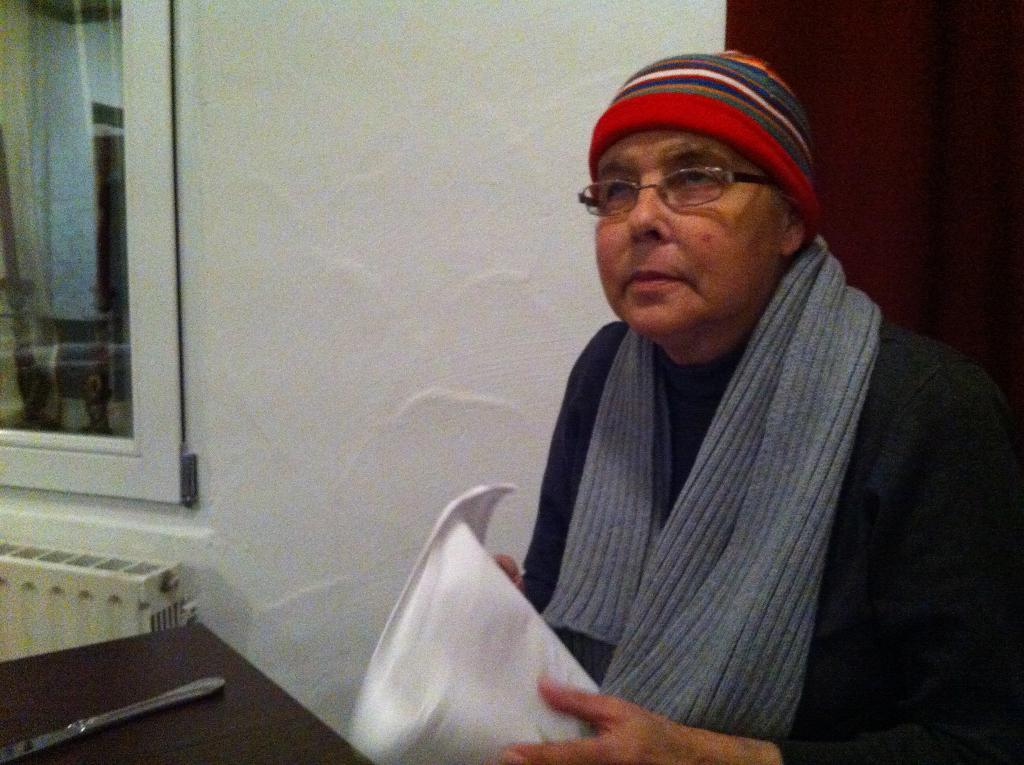What is the person in the image doing? The person is sitting in the image. What is the person holding in the image? The person is holding an object. What is on the table in front of the person? There is a table in front of the person, and a knife is present on the table. What can be seen in the background of the image? There is a wall and a window in the background of the image. How does the person wave to the part of the room that is not visible in the image? The person is not waving to any part of the room in the image, as they are sitting and holding an object. 